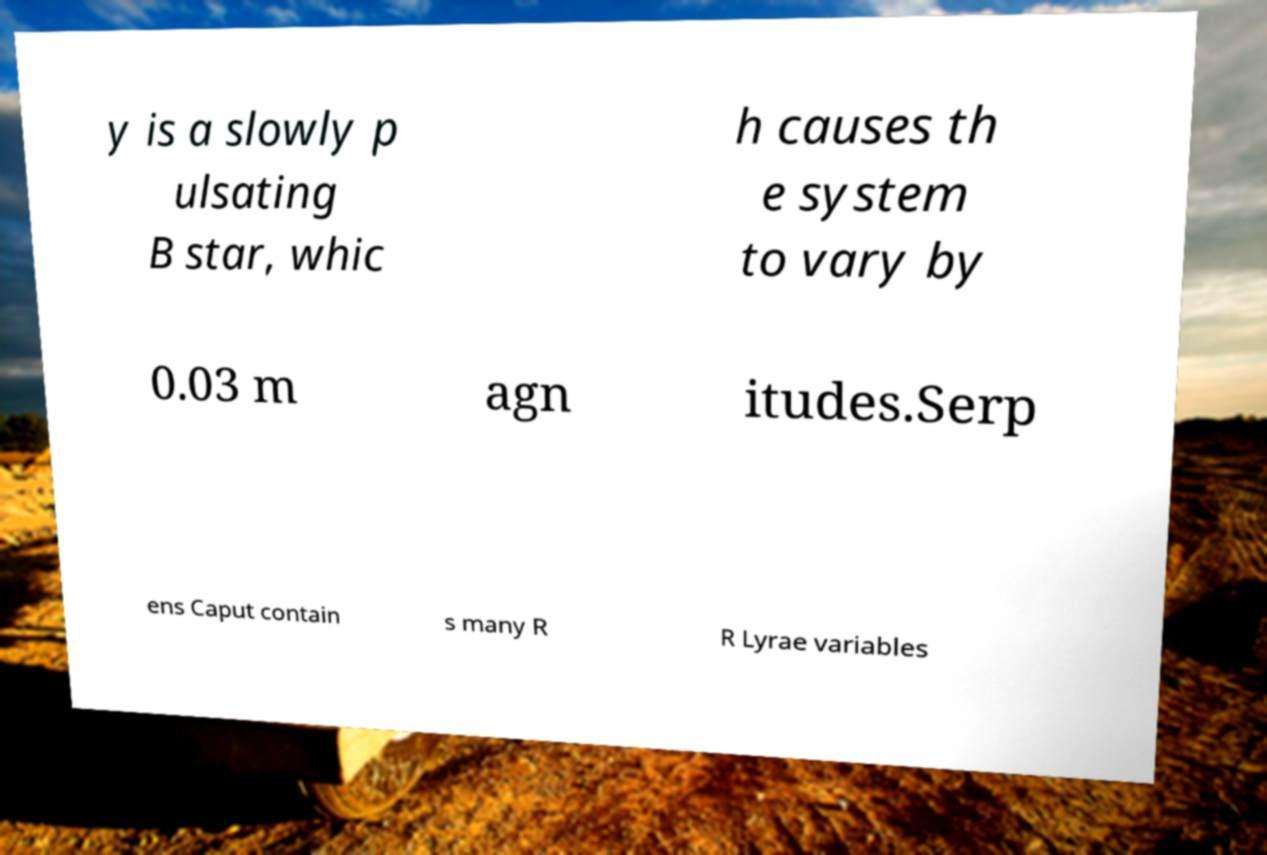Could you extract and type out the text from this image? y is a slowly p ulsating B star, whic h causes th e system to vary by 0.03 m agn itudes.Serp ens Caput contain s many R R Lyrae variables 